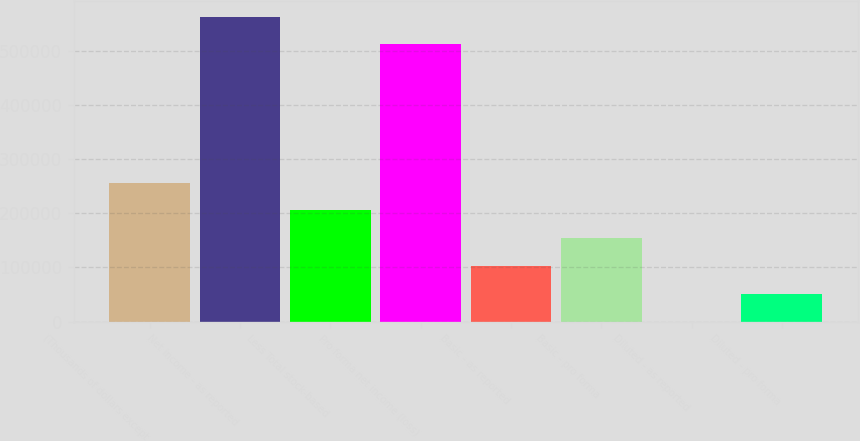<chart> <loc_0><loc_0><loc_500><loc_500><bar_chart><fcel>(Thousands of dollars except<fcel>Net income - as reported<fcel>Less Total stock-based<fcel>Pro forma net income (loss)<fcel>Basic - as reported<fcel>Basic - pro forma<fcel>Diluted - as reported<fcel>Diluted - pro forma<nl><fcel>256487<fcel>563089<fcel>205190<fcel>511792<fcel>102595<fcel>153892<fcel>1.23<fcel>51298.3<nl></chart> 